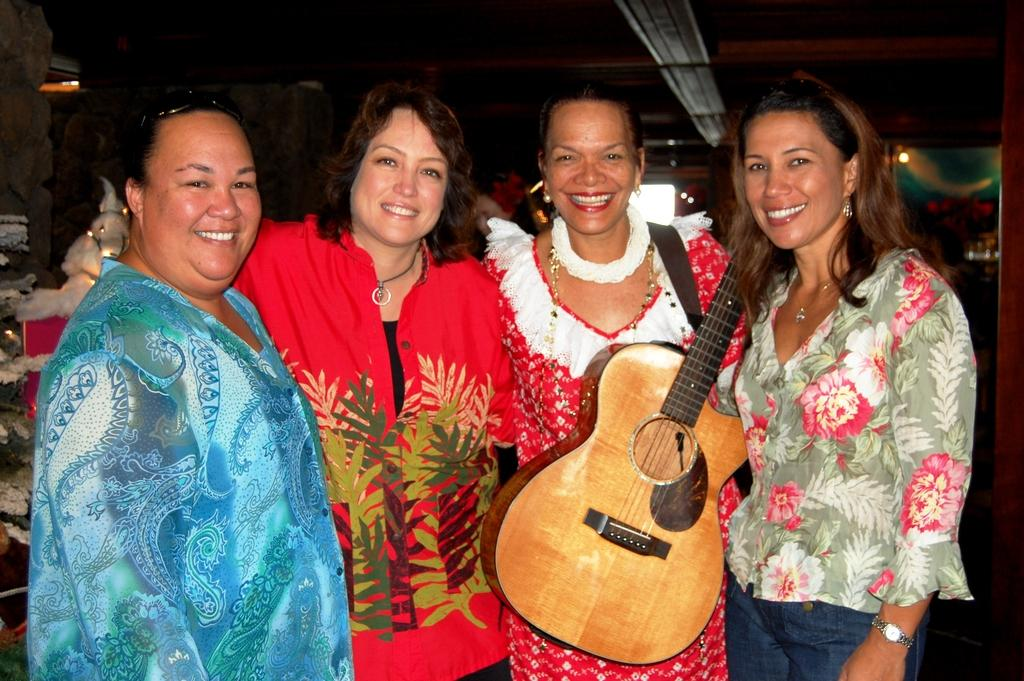How many people are in the image? There are four ladies in the image. What is one of the ladies holding? One of the ladies is holding a guitar. What type of liquid is being poured from the guitar in the image? There is no liquid being poured from the guitar in the image; it is a solid instrument. 